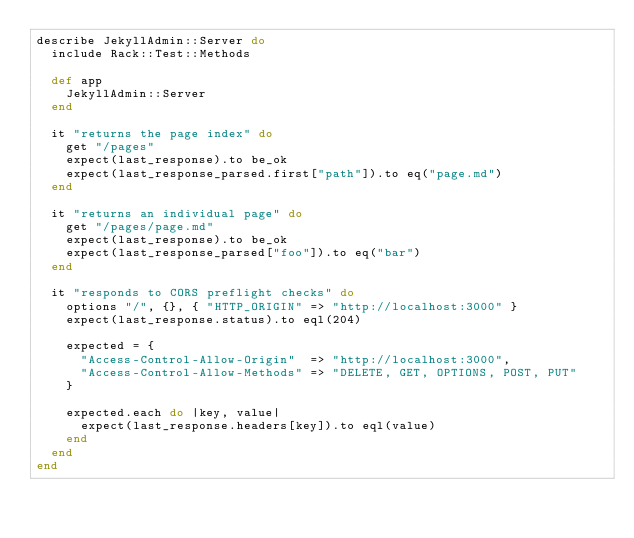<code> <loc_0><loc_0><loc_500><loc_500><_Ruby_>describe JekyllAdmin::Server do
  include Rack::Test::Methods

  def app
    JekyllAdmin::Server
  end

  it "returns the page index" do
    get "/pages"
    expect(last_response).to be_ok
    expect(last_response_parsed.first["path"]).to eq("page.md")
  end

  it "returns an individual page" do
    get "/pages/page.md"
    expect(last_response).to be_ok
    expect(last_response_parsed["foo"]).to eq("bar")
  end

  it "responds to CORS preflight checks" do
    options "/", {}, { "HTTP_ORIGIN" => "http://localhost:3000" }
    expect(last_response.status).to eql(204)

    expected = {
      "Access-Control-Allow-Origin"  => "http://localhost:3000",
      "Access-Control-Allow-Methods" => "DELETE, GET, OPTIONS, POST, PUT"
    }

    expected.each do |key, value|
      expect(last_response.headers[key]).to eql(value)
    end
  end
end
</code> 